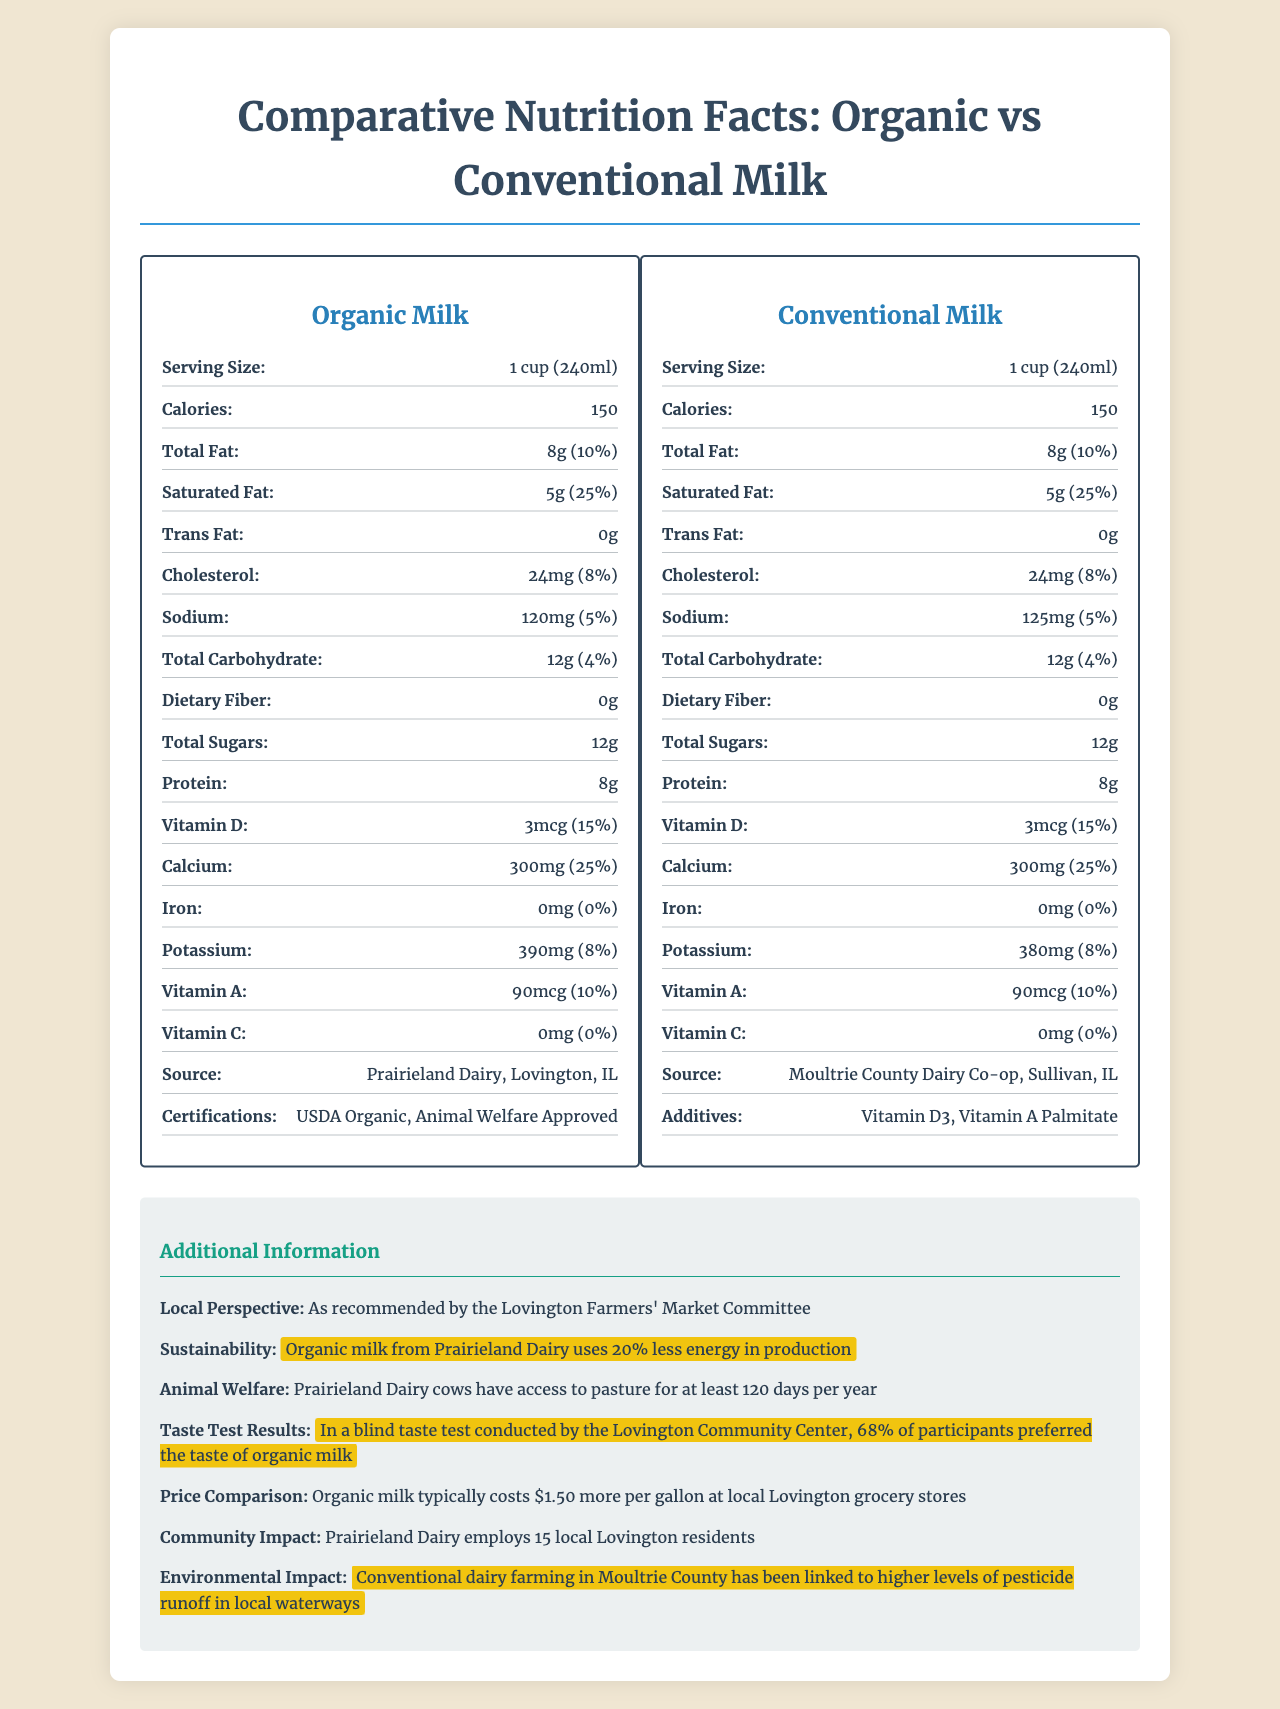what is the serving size for organic milk? The serving size for organic milk is clearly mentioned in the document as "1 cup (240ml)".
Answer: 1 cup (240ml) what is the daily value percentage of calcium in conventional milk? The document lists the calcium daily value for conventional milk as 25%.
Answer: 25% how much sodium is in organic milk? The sodium content in organic milk is specified as 120mg.
Answer: 120mg how much does organic milk cost more per gallon at local Lovington grocery stores? Under the "Additional Information" section, the price comparison shows that organic milk typically costs $1.50 more per gallon.
Answer: $1.50 more how much potassium is in conventional milk? The potassium content in conventional milk is listed as 380mg.
Answer: 380mg what is the source of organic milk? A. Prairieland Dairy B. Moultrie County Dairy Co-op C. Lovington Milk Farm The source of organic milk is given as Prairieland Dairy, Lovington, IL.
Answer: A. Prairieland Dairy which type of milk has additives? A. Organic Milk B. Conventional Milk C. Both D. Neither The conventional milk has additives listed as "Vitamin D3" and "Vitamin A Palmitate".
Answer: B. Conventional Milk does organic milk contain any iron? The nutrition label for organic milk indicates 0mg of iron (0% daily value).
Answer: No provide a summary of the differences between organic and conventional milk based on the document. The document illustrates several differences: nutritional similarities, certifications, sustainability, animal welfare practices, taste test preferences, price comparison, and community impact.
Answer: Organic milk is considered to have better sustainability and animal welfare standards, with cows having access to pasture for at least 120 days per year. It typically costs more but was preferred in a community taste test. Both types of milk have similar nutritional profiles, though conventional milk includes additives, while organic milk is certified by USDA Organic and Animal Welfare Approved. which dairy farm employs local residents? According to the "Additional Information" section, Prairieland Dairy employs 15 local Lovington residents.
Answer: Prairieland Dairy how much daily value of Vitamin D does organic milk provide? The Vitamin D daily value for organic milk is listed as 15%.
Answer: 15% what percentage of participants preferred the taste of organic milk in the taste test? A taste test conducted by the Lovington Community Center resulted in 68% of participants preferring organic milk.
Answer: 68% is there any mention of pesticide runoff in the document? The "environmental impact" section discusses that conventional dairy farming in Moultrie County has been linked to higher levels of pesticide runoff in local waterways.
Answer: Yes why is the information about irons' daily value absent? The document does not provide any information on why the iron daily value is absent; it's simply listed as 0mg in both types of milk.
Answer: Cannot be determined 